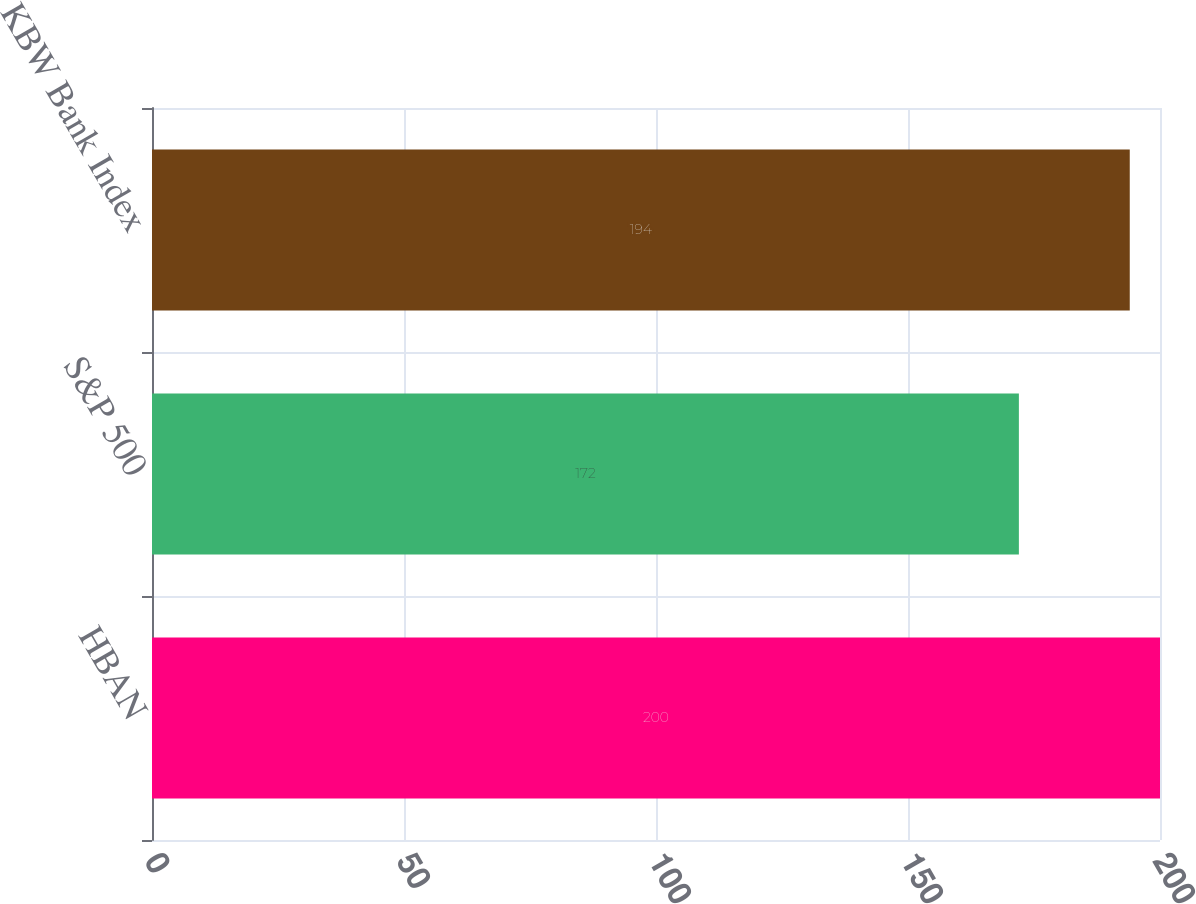Convert chart. <chart><loc_0><loc_0><loc_500><loc_500><bar_chart><fcel>HBAN<fcel>S&P 500<fcel>KBW Bank Index<nl><fcel>200<fcel>172<fcel>194<nl></chart> 